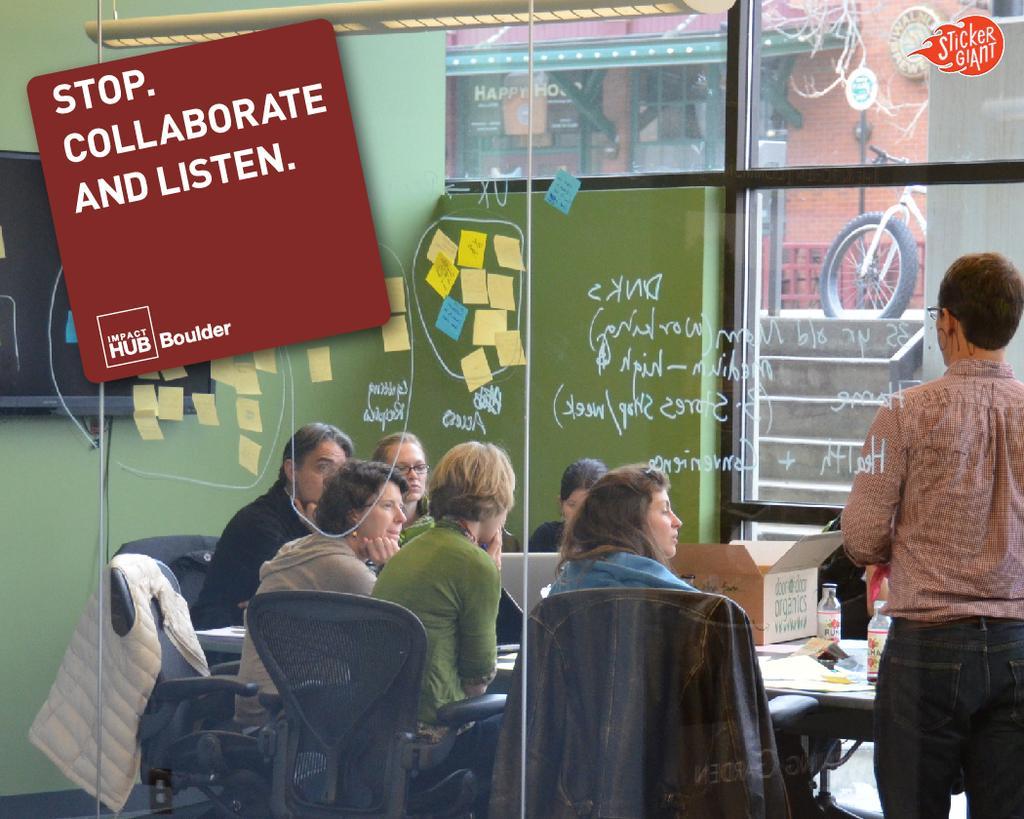Can you describe this image briefly? This image is clicked inside the room. There are many people sitting in the chair around the table. To the right, the man standing is wearing a black jeans. To the left, there is a sticker in red color. In the front, there is a glass. In the middle, the woman sitting in the chair is wearing green dress. 